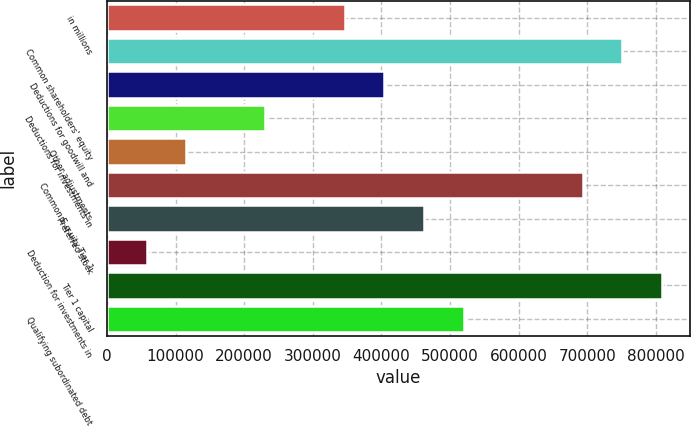Convert chart. <chart><loc_0><loc_0><loc_500><loc_500><bar_chart><fcel>in millions<fcel>Common shareholders' equity<fcel>Deductions for goodwill and<fcel>Deductions for investments in<fcel>Other adjustments<fcel>Common E q uity Tier 1<fcel>Preferred stock<fcel>Deduction for investments in<fcel>Tier 1 capital<fcel>Qualifying subordinated debt<nl><fcel>346594<fcel>750944<fcel>404358<fcel>231066<fcel>115538<fcel>693179<fcel>462123<fcel>57773.5<fcel>808708<fcel>519887<nl></chart> 